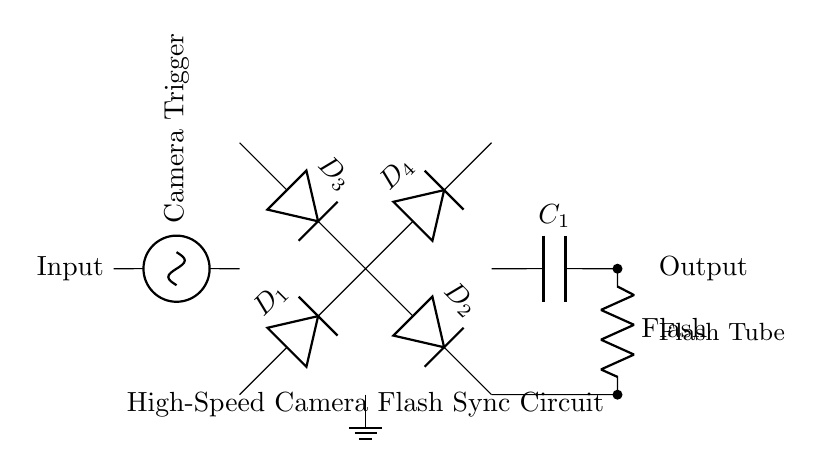What type of rectifier is used in this circuit? The circuit utilizes a bridge rectifier, which consists of four diodes arranged in a bridge configuration to convert AC to DC.
Answer: bridge rectifier How many diodes are there in the circuit? There are four diodes in total: D1, D2, D3, and D4, which work together to rectify the alternating current into direct current.
Answer: four diodes What is the purpose of the capacitor in this circuit? The capacitor (C1) smoothens the output voltage by storing charge and releasing it when needed, providing a more stable DC voltage for the flash.
Answer: smooth output voltage What component acts as the load in this circuit? The load in this circuit is the flash, which is connected in parallel to the capacitor and uses the rectified DC current to produce a flash of light.
Answer: Flash What is the input to the circuit? The input to the circuit is the camera trigger signal, which initiates the rectification process and subsequently triggers the flash when activated.
Answer: Camera Trigger Which element is used to ground the circuit? The ground in this circuit is provided by the node connected through the resistor to the lower side of the diodes (bottom node), ensuring proper reference and stability.
Answer: ground What allows the circuit to function with alternating current? The arrangement of the four diodes in a bridge configuration allows the circuit to handle alternating current effectively by channeling both halves of the AC waveform into the same polarity for the output.
Answer: bridge configuration 